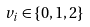Convert formula to latex. <formula><loc_0><loc_0><loc_500><loc_500>v _ { i } \in \{ 0 , 1 , 2 \}</formula> 